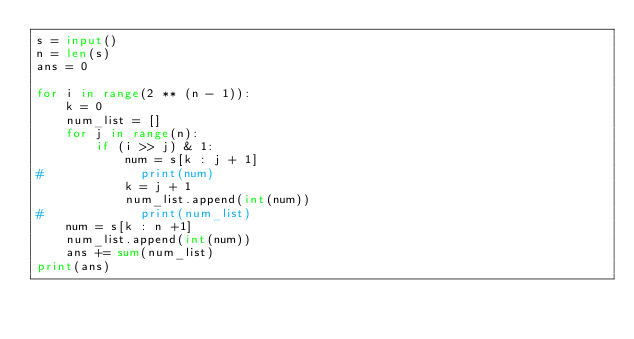Convert code to text. <code><loc_0><loc_0><loc_500><loc_500><_Python_>s = input()
n = len(s)
ans = 0

for i in range(2 ** (n - 1)):
    k = 0
    num_list = []
    for j in range(n):
        if (i >> j) & 1:
            num = s[k : j + 1]
#             print(num)
            k = j + 1
            num_list.append(int(num))
#             print(num_list)
    num = s[k : n +1]
    num_list.append(int(num))
    ans += sum(num_list)
print(ans)</code> 